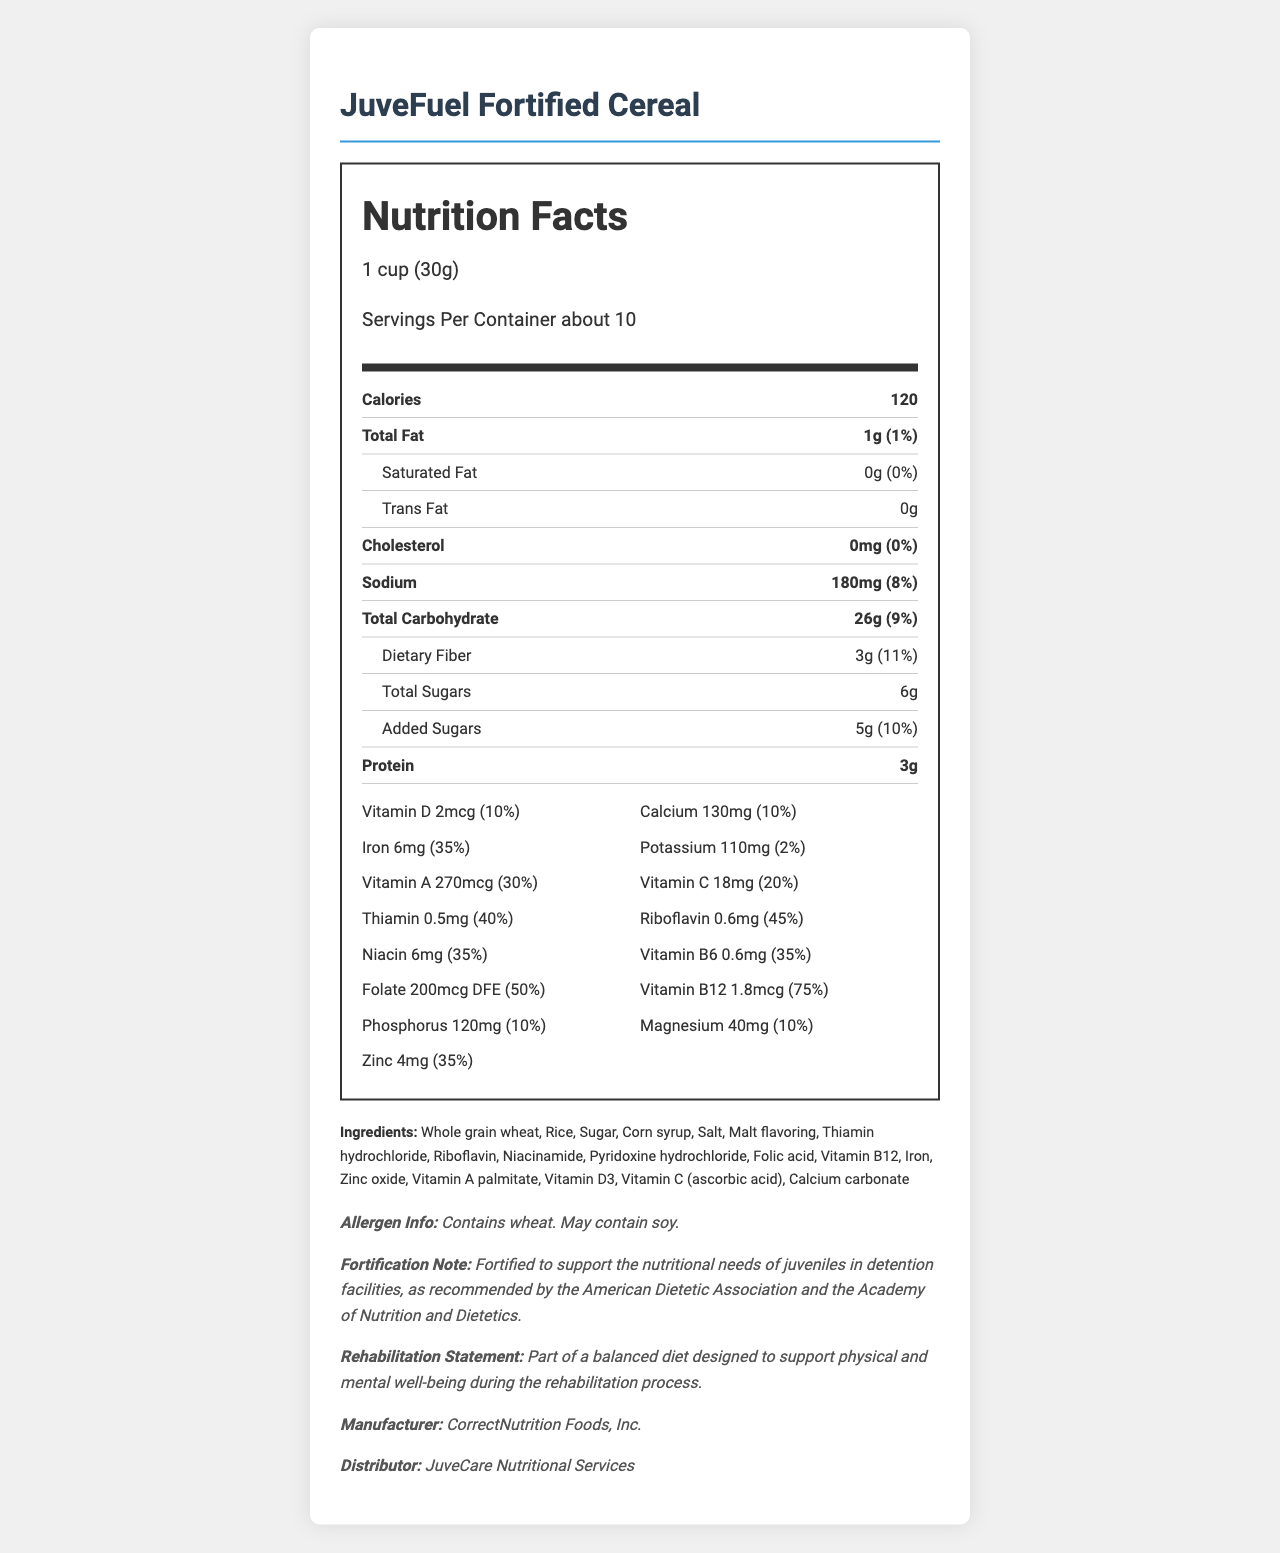how many grams of dietary fiber are in one serving? The document states that each serving (1 cup or 30g) of JuveFuel Fortified Cereal contains 3 grams of dietary fiber.
Answer: 3 grams what is the serving size for JuveFuel Fortified Cereal? The document specifies that the serving size is 1 cup, which is equivalent to 30 grams.
Answer: 1 cup (30g) how much iron does one serving of the cereal provide? The Nutrition Facts label shows that one serving provides 6mg of iron.
Answer: 6mg what percentage of the daily value for Vitamin C is in one serving? The document lists that one serving contains 18mg of Vitamin C, which is 20% of the daily value.
Answer: 20% does the cereal contain any trans fats? According to the document, the amount of trans fat in the cereal is 0g.
Answer: No how many calories are in one serving of JuveFuel Fortified Cereal? A. 100 B. 120 C. 150 D. 180 The document states that one serving contains 120 calories.
Answer: B which of the following vitamins is present in the highest daily value percentage? A. Vitamin D B. Thiamin C. Vitamin B12 D. Niacin The document shows Vitamin B12 at 75% of the daily value, which is the highest among the listed options.
Answer: C does the cereal contain soy? The allergen information in the document mentions that the cereal may contain soy.
Answer: May contain summarize the main idea of the document. The document presents a comprehensive Nutrition Facts label of JuveFuel Fortified Cereal, intended for juvenile detention facilities. It highlights the product's nutritional content, including vitamins, minerals, calories, and allergens, while emphasizing its role in supporting the dietary needs of juveniles in a rehabilitative setting.
Answer: JuveFuel Fortified Cereal is a nutritious breakfast option specifically designed for juvenile detention facilities, providing a balanced mix of essential vitamins and minerals needed for physical and mental well-being. The label includes nutritional information such as serving size, calorie count, and the percentage of daily values of various nutrients, along with allergen information and the purpose of fortification. how many ingredients are listed for JuveFuel Fortified Cereal? The document lists 17 ingredients in the cereal.
Answer: 17 what is the fortification note for JuveFuel Fortified Cereal? The document includes a specific note stating that the cereal is fortified to meet the nutritional needs of juveniles in detention, following recommendations from reputable organizations.
Answer: Fortified to support the nutritional needs of juveniles in detention facilities, as recommended by the American Dietetic Association and the Academy of Nutrition and Dietetics. who manufactures the JuveFuel Fortified Cereal? The document mentions that CorrectNutrition Foods, Inc. is the manufacturer.
Answer: CorrectNutrition Foods, Inc. is the sodium content greater than the protein content in one serving of JuveFuel Fortified Cereal? The document shows the sodium content as 180mg and the protein content as 3g. Since 1g is equivalent to 1000mg, 180mg of sodium is greater than 3g (or 3000mg) of protein. Hence, the sodium content is greater than the protein content.
Answer: Yes what is the main source of carbohydrates in the cereal? The document lists several ingredients such as whole grain wheat, rice, sugar, and corn syrup, but does not specify which one is the main source of carbohydrates.
Answer: Cannot be determined 